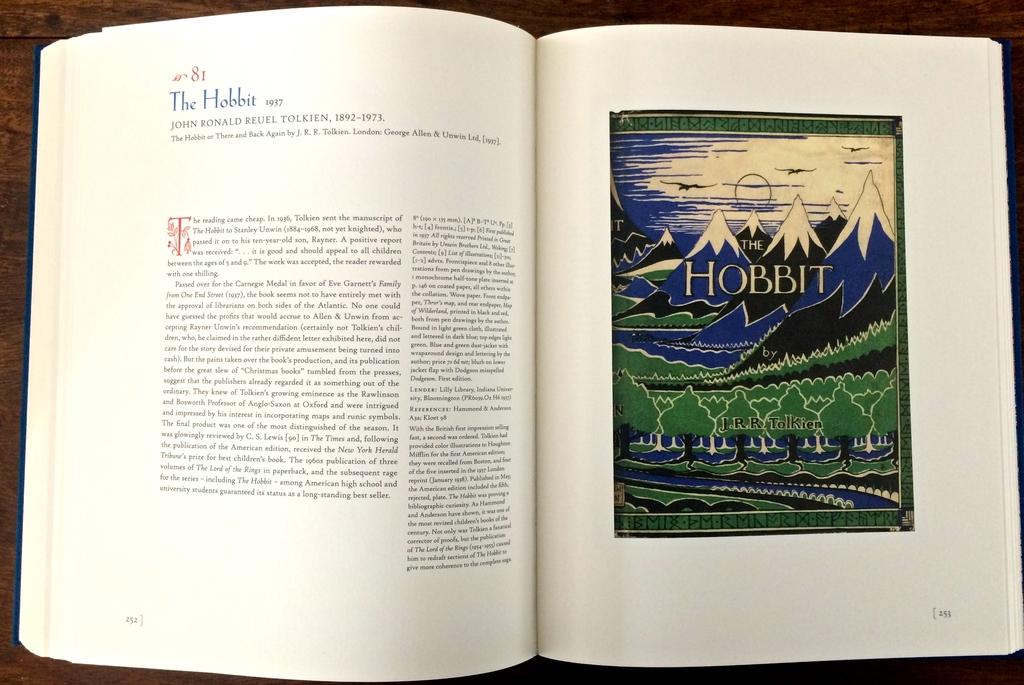What is the name of this book?
Ensure brevity in your answer.  The hobbit. What chapter are they on?
Your answer should be very brief. 81. 